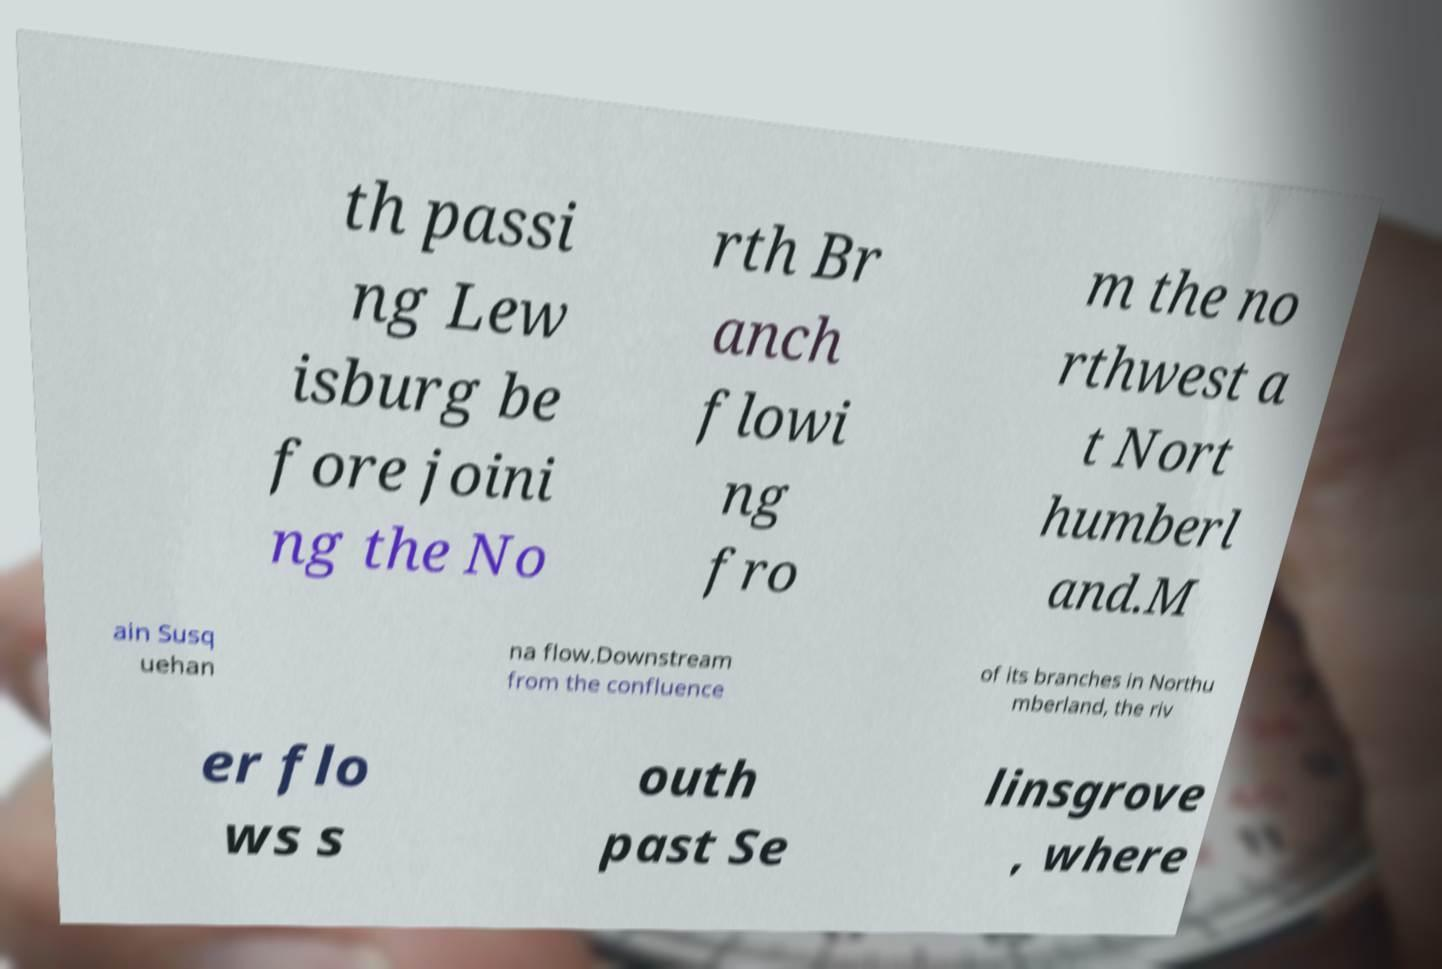What messages or text are displayed in this image? I need them in a readable, typed format. th passi ng Lew isburg be fore joini ng the No rth Br anch flowi ng fro m the no rthwest a t Nort humberl and.M ain Susq uehan na flow.Downstream from the confluence of its branches in Northu mberland, the riv er flo ws s outh past Se linsgrove , where 